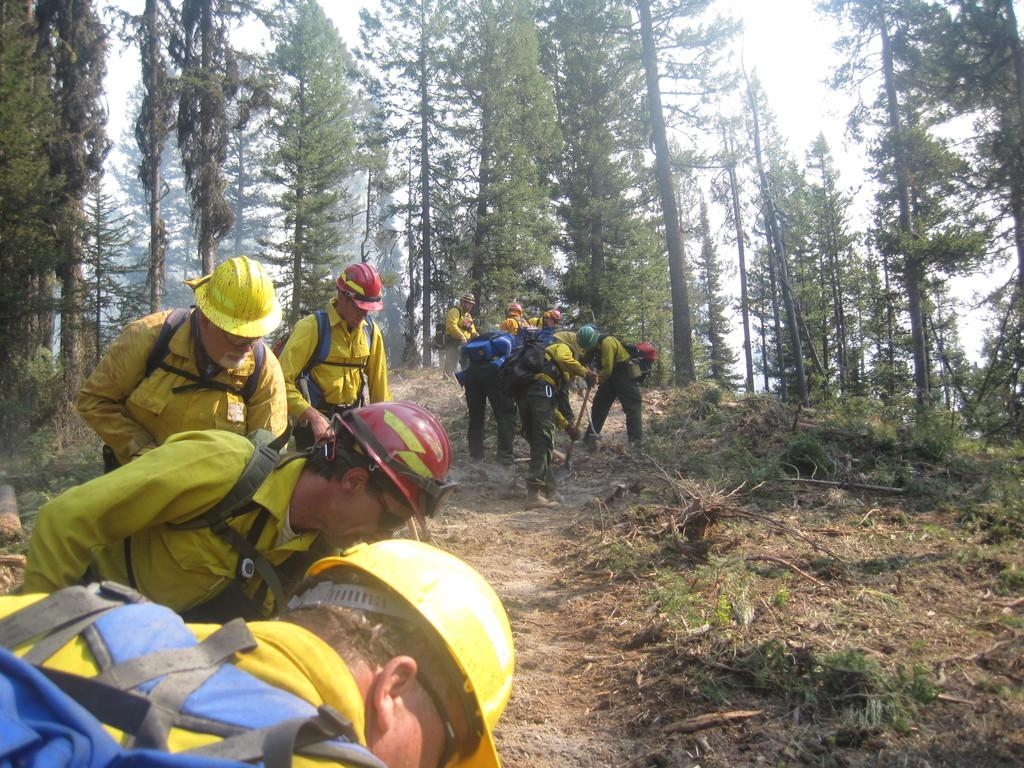What are the people in the image wearing on their heads? The people in the image are wearing helmets. What color are the dresses worn by the people in the image? The people are wearing yellow color dresses. What type of terrain is visible in the image? There is grass in the image. What else can be seen in the image besides the people and grass? There are trees in the image. What is visible at the top of the image? The sky is visible at the top of the image. Can you tell me how many managers are present in the image? There is no mention of a manager in the image; it features people wearing helmets and yellow dresses, grass, trees, and a visible sky. 